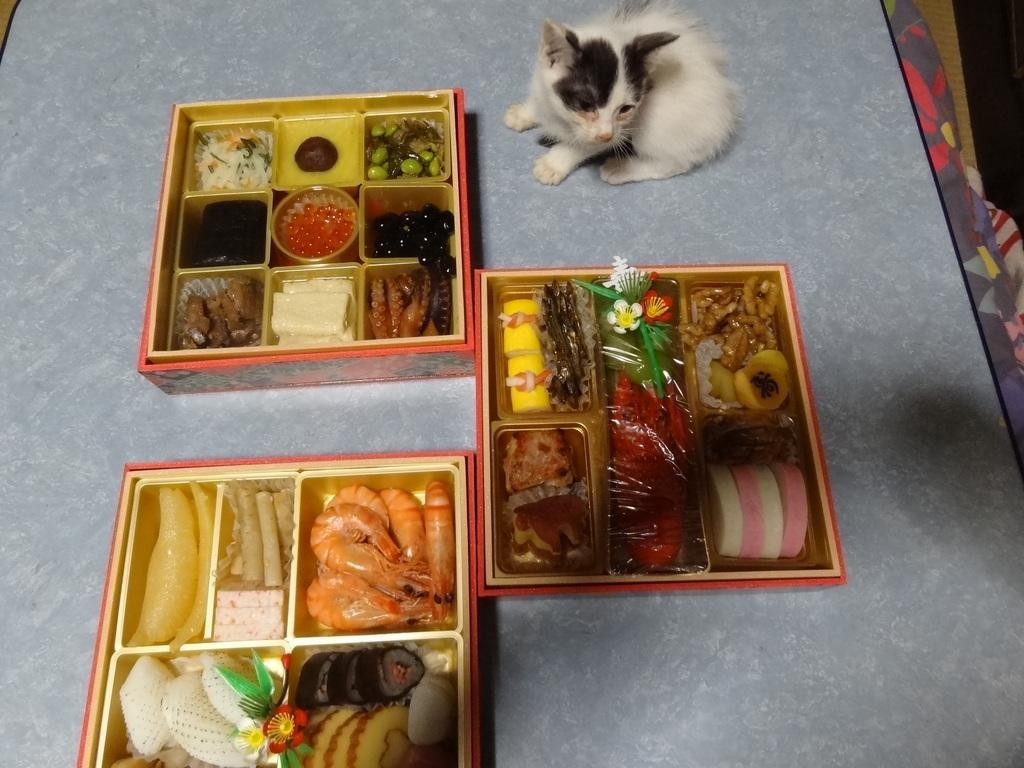How many boxes are visible in the image? There are three boxes in the image. What is inside the boxes? The boxes contain food items. What animal can be seen in the image? There is a cat sitting on a surface. What type of surface is the cat sitting on? The surface resembles a table. What color is the balloon that the cat is holding in the image? There is no balloon present in the image, and the cat is not holding anything. 